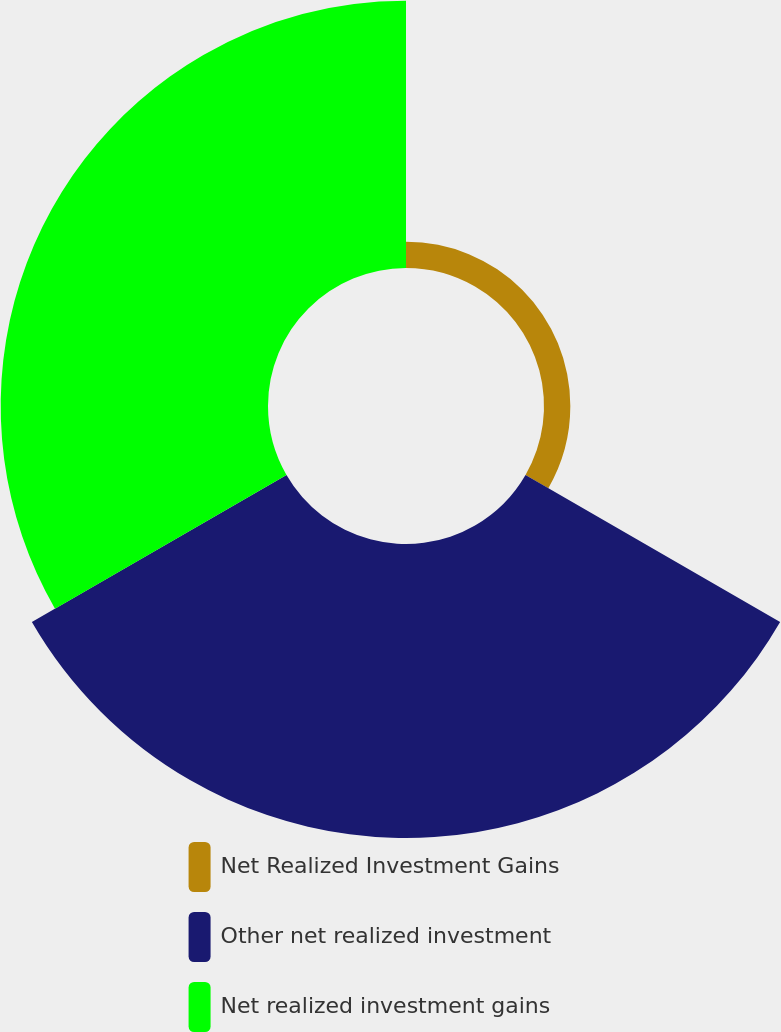Convert chart to OTSL. <chart><loc_0><loc_0><loc_500><loc_500><pie_chart><fcel>Net Realized Investment Gains<fcel>Other net realized investment<fcel>Net realized investment gains<nl><fcel>4.48%<fcel>50.03%<fcel>45.49%<nl></chart> 